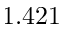Convert formula to latex. <formula><loc_0><loc_0><loc_500><loc_500>1 . 4 2 1</formula> 